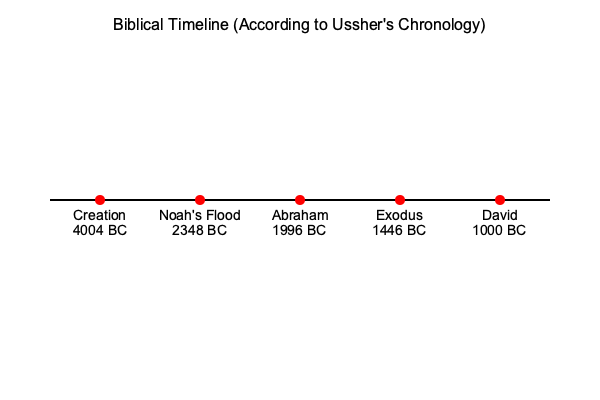Based on the biblical timeline shown in the chart, approximately how many years passed between the Creation and the reign of King David? To determine the number of years between the Creation and the reign of King David, we need to follow these steps:

1. Identify the dates for both events on the timeline:
   - Creation: 4004 BC
   - David's reign: 1000 BC

2. Calculate the difference between these two dates:
   $4004 - 1000 = 3004$

3. The result represents the number of years that passed between these two events.

It's important to note that this timeline is based on Ussher's Chronology, which is one interpretation of biblical genealogies and may not be universally accepted by all scholars or denominations. As a pastor, understanding various interpretations of biblical timelines can be valuable for teaching and discussing the historical context of Scripture.
Answer: Approximately 3,000 years 